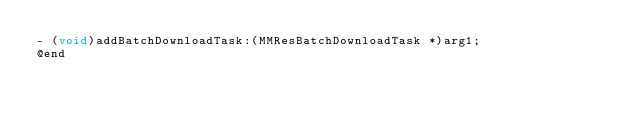<code> <loc_0><loc_0><loc_500><loc_500><_C_>- (void)addBatchDownloadTask:(MMResBatchDownloadTask *)arg1;
@end

</code> 